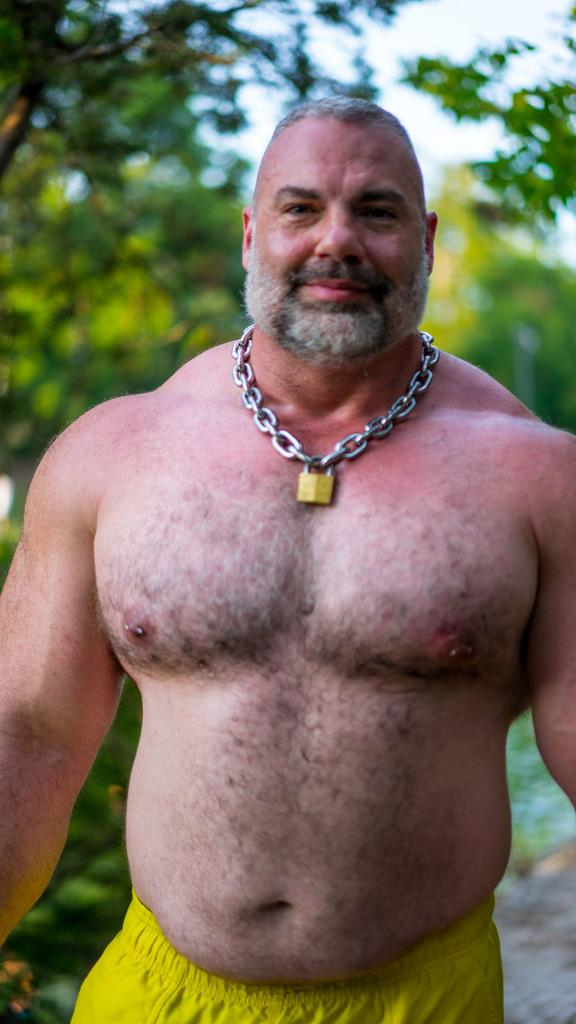Who or what is present in the image? There is a person in the image. What can be seen in the distance behind the person? There are trees in the background of the image. How many birds can be seen perched on the root in the image? There are no birds or roots present in the image. 